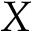<formula> <loc_0><loc_0><loc_500><loc_500>{ X }</formula> 